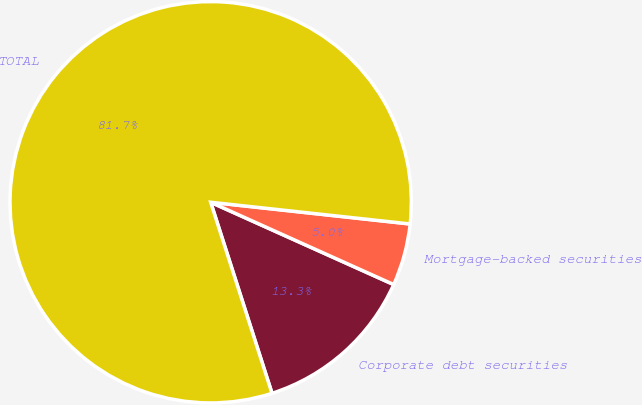<chart> <loc_0><loc_0><loc_500><loc_500><pie_chart><fcel>Corporate debt securities<fcel>Mortgage-backed securities<fcel>TOTAL<nl><fcel>13.33%<fcel>5.0%<fcel>81.67%<nl></chart> 